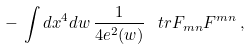<formula> <loc_0><loc_0><loc_500><loc_500>- \, \int d x ^ { 4 } d w \, \frac { 1 } { 4 e ^ { 2 } ( w ) } \, \ t r F _ { m n } F ^ { m n } \, ,</formula> 